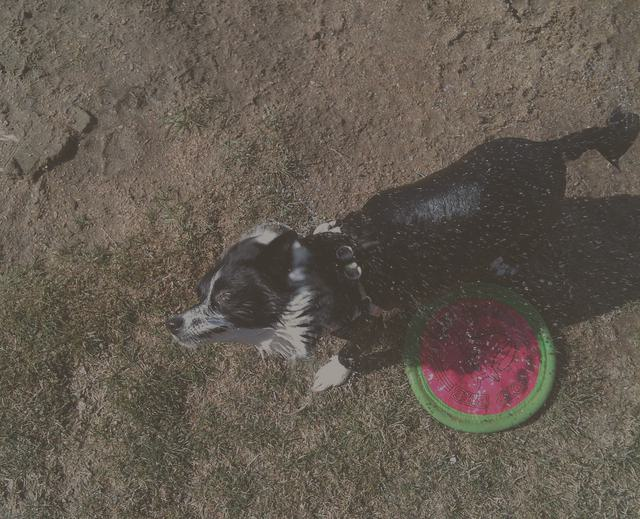Describe the setting where the dog is located. The dog is situated outdoors on a patch of grass that appears somewhat dry and patchy. Judging by the lack of other greenery or trees in the immediate vicinity of the photo, it could be a backyard or a public park. The sunlight indicates it might be midday. This sort of environment is common for dogs to play and exercise in. 